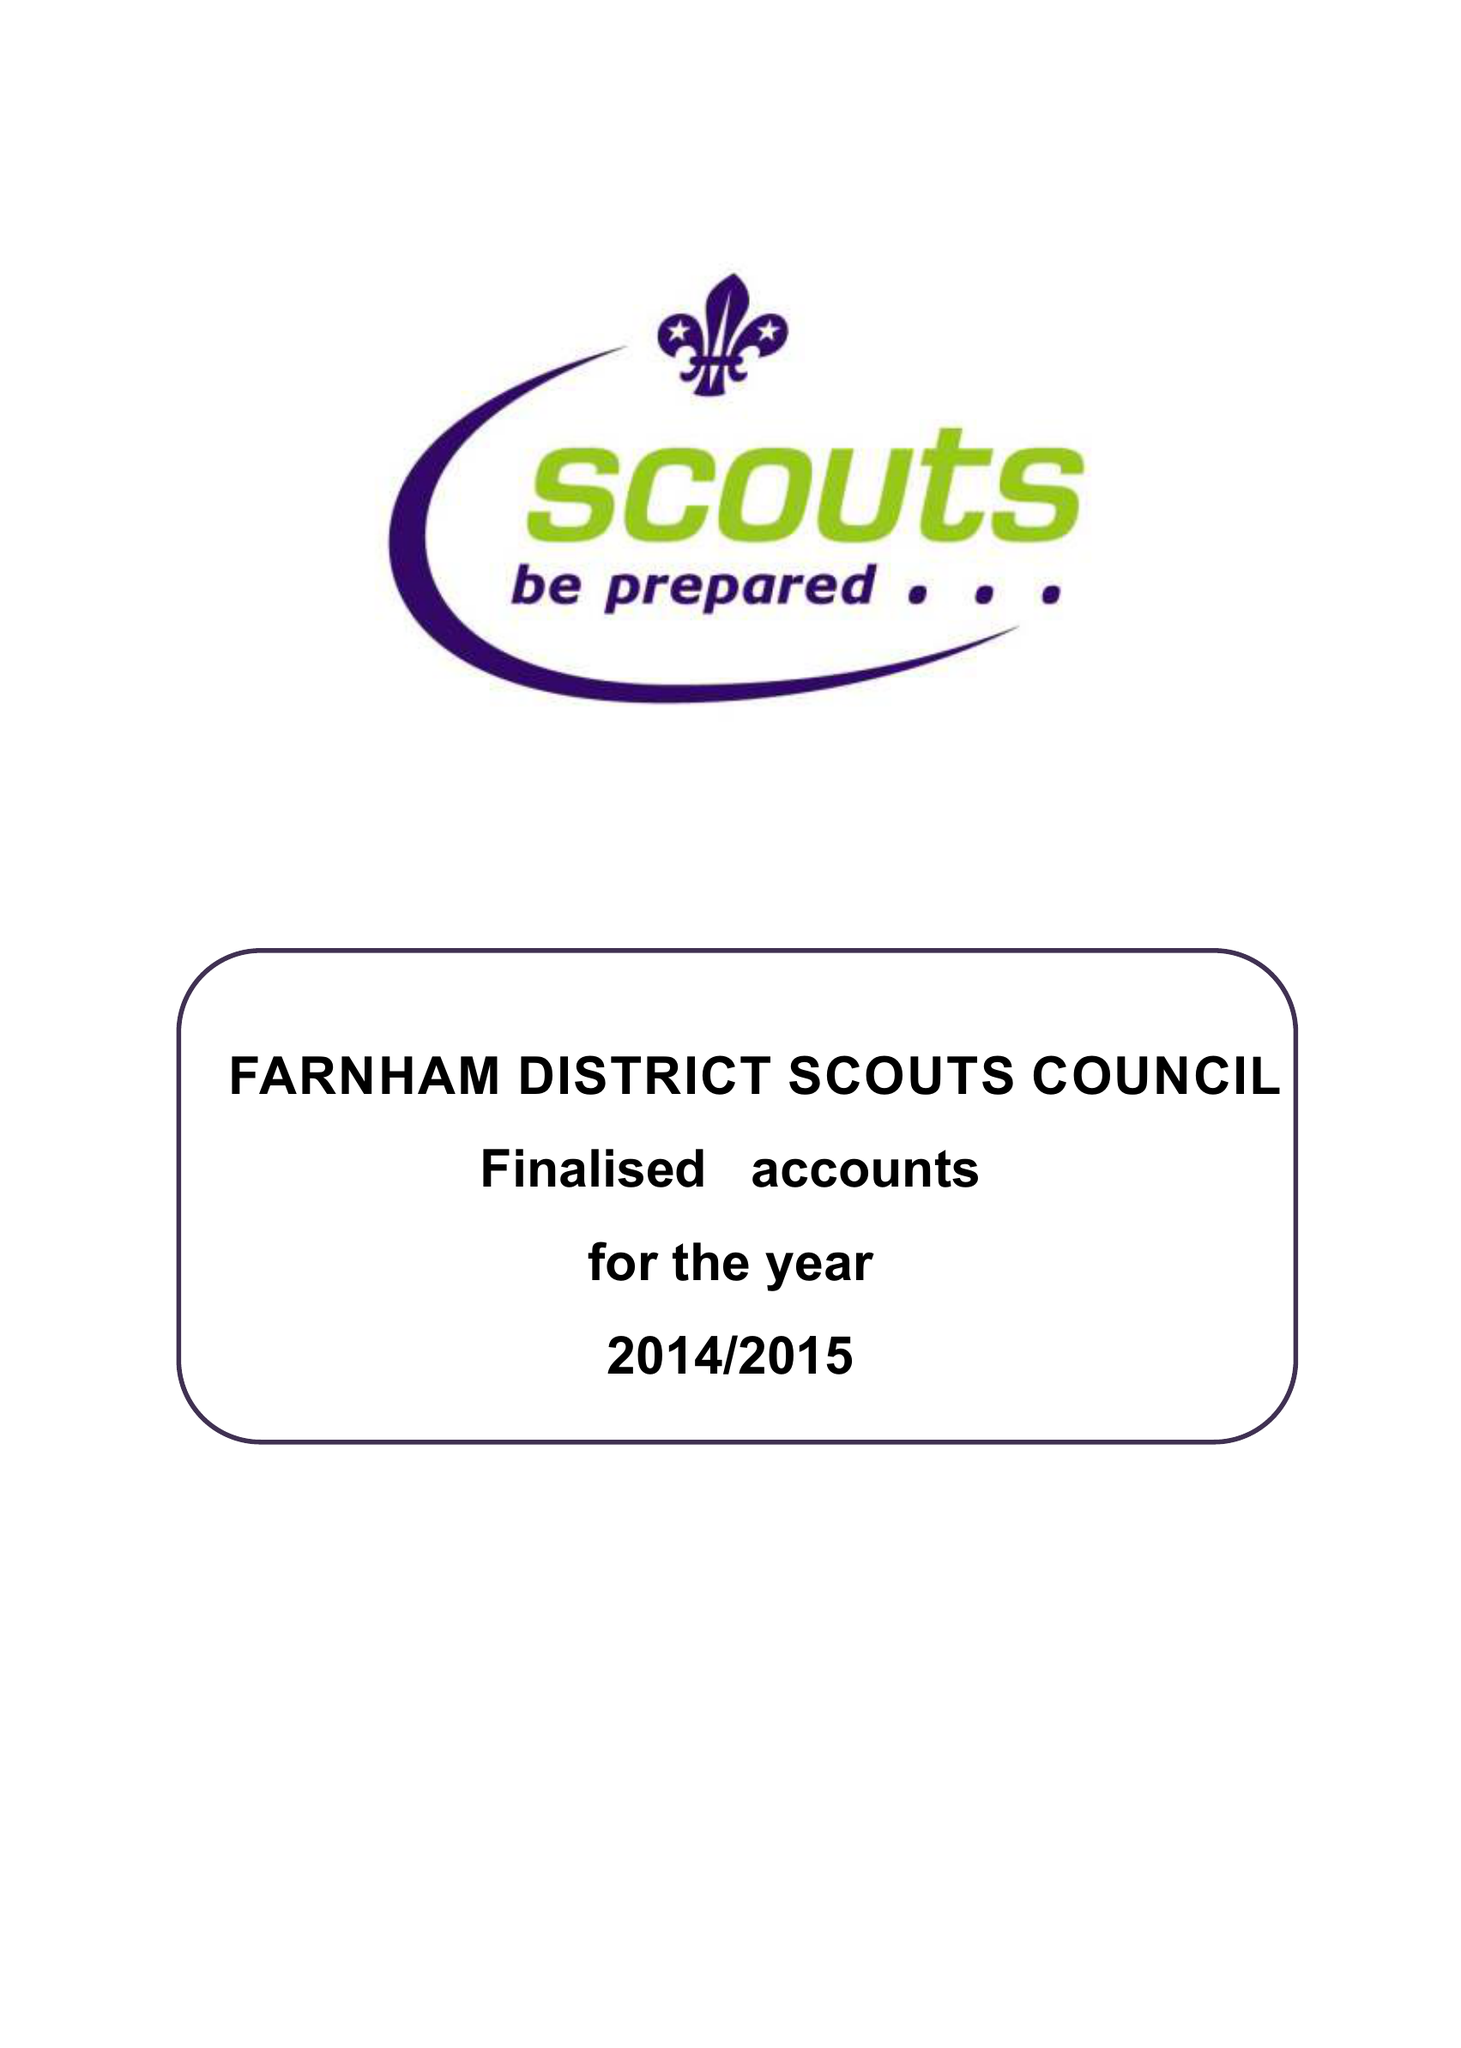What is the value for the charity_number?
Answer the question using a single word or phrase. 1020617 